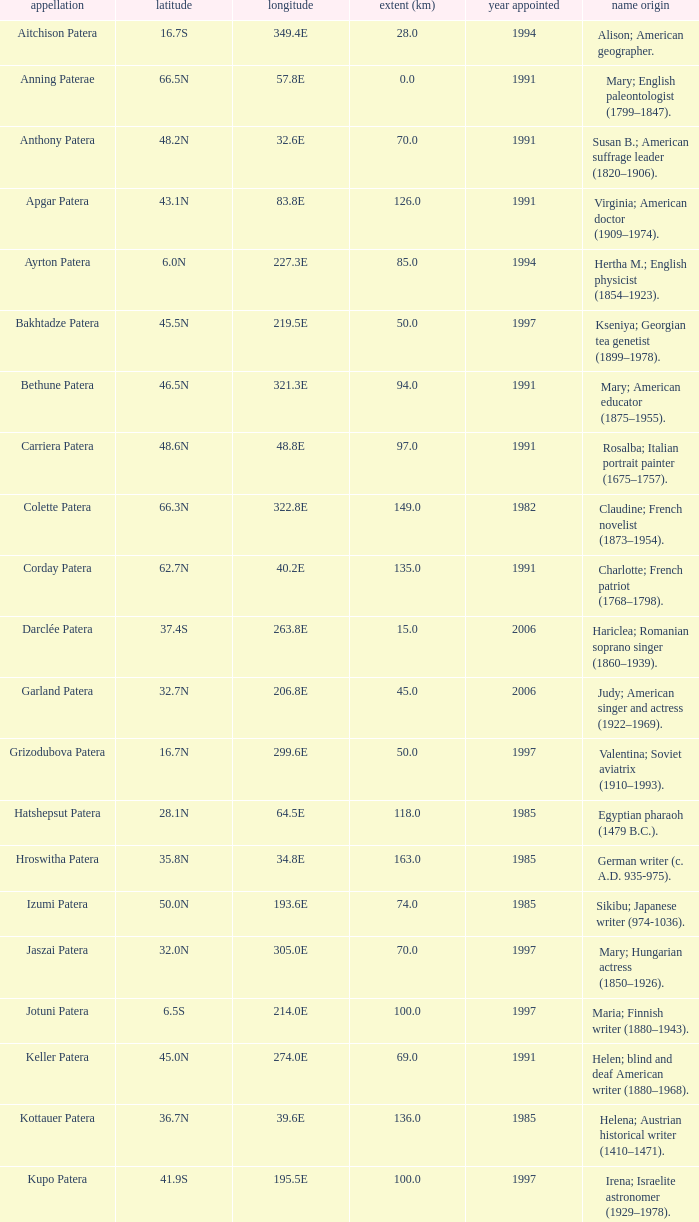What is  the diameter in km of the feature with a longitude of 40.2E?  135.0. 